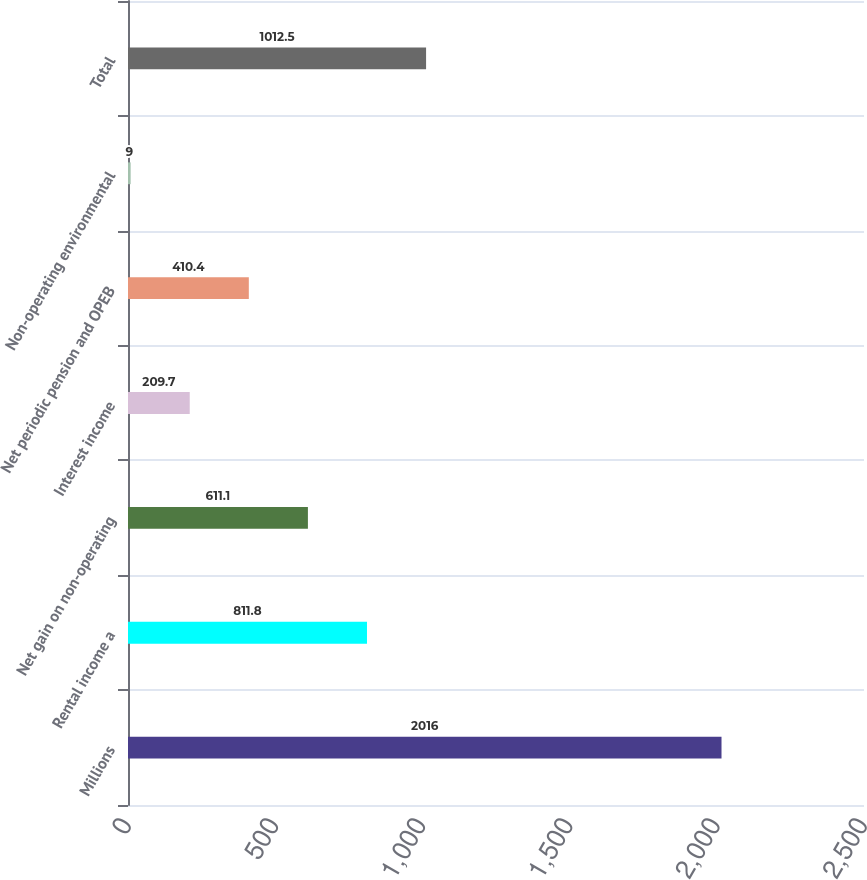<chart> <loc_0><loc_0><loc_500><loc_500><bar_chart><fcel>Millions<fcel>Rental income a<fcel>Net gain on non-operating<fcel>Interest income<fcel>Net periodic pension and OPEB<fcel>Non-operating environmental<fcel>Total<nl><fcel>2016<fcel>811.8<fcel>611.1<fcel>209.7<fcel>410.4<fcel>9<fcel>1012.5<nl></chart> 